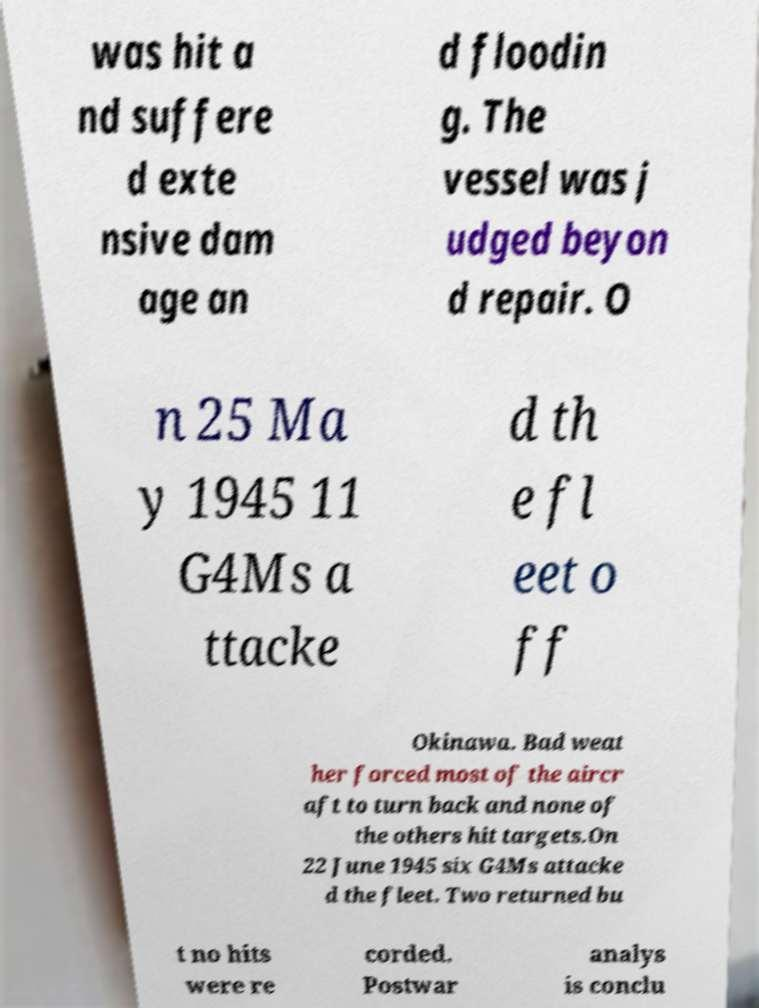What messages or text are displayed in this image? I need them in a readable, typed format. was hit a nd suffere d exte nsive dam age an d floodin g. The vessel was j udged beyon d repair. O n 25 Ma y 1945 11 G4Ms a ttacke d th e fl eet o ff Okinawa. Bad weat her forced most of the aircr aft to turn back and none of the others hit targets.On 22 June 1945 six G4Ms attacke d the fleet. Two returned bu t no hits were re corded. Postwar analys is conclu 